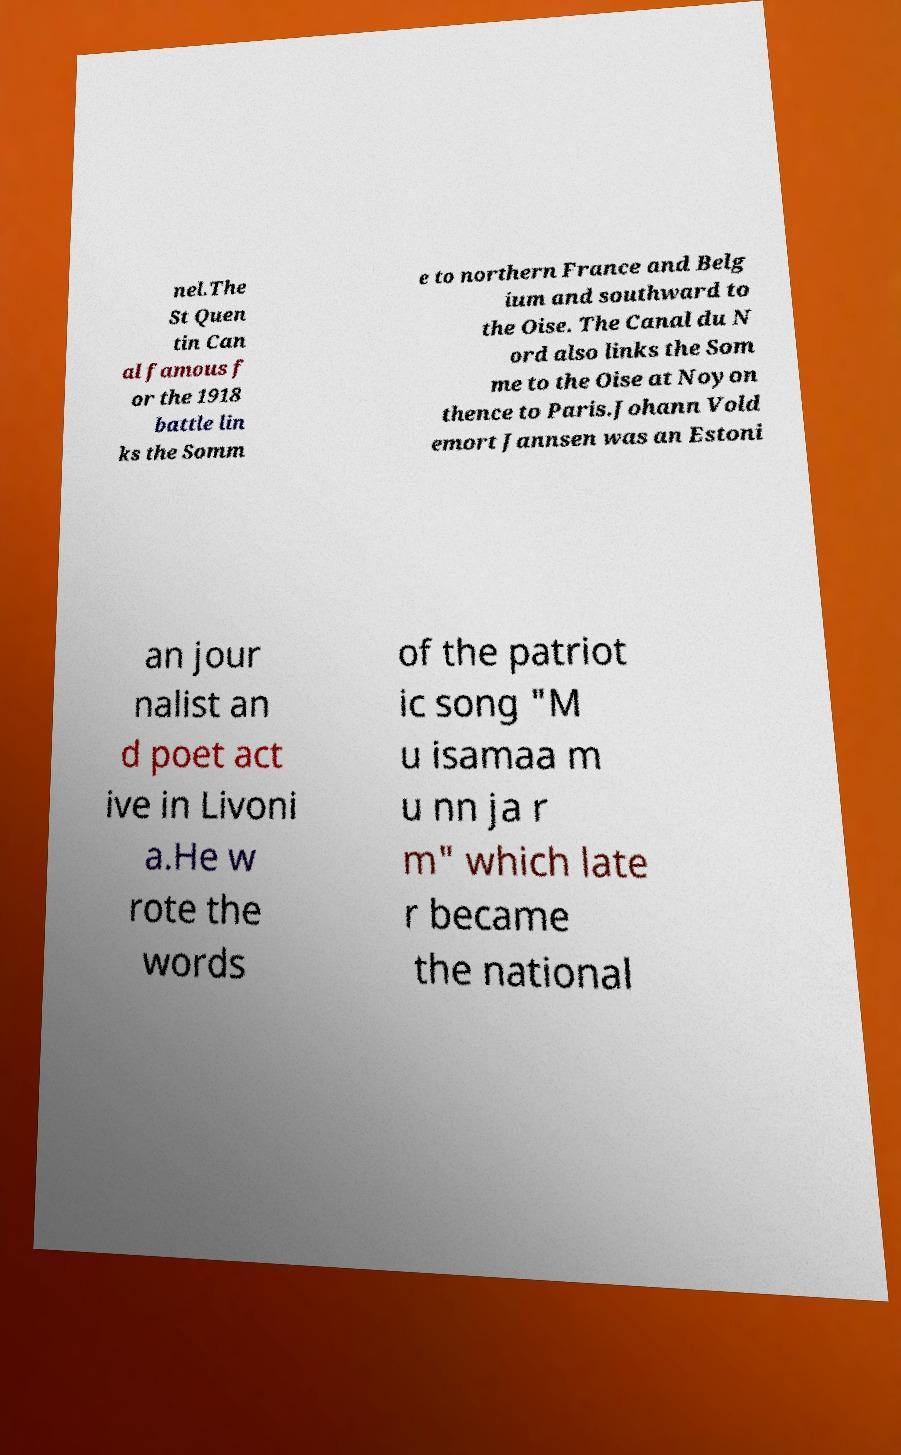Could you assist in decoding the text presented in this image and type it out clearly? nel.The St Quen tin Can al famous f or the 1918 battle lin ks the Somm e to northern France and Belg ium and southward to the Oise. The Canal du N ord also links the Som me to the Oise at Noyon thence to Paris.Johann Vold emort Jannsen was an Estoni an jour nalist an d poet act ive in Livoni a.He w rote the words of the patriot ic song "M u isamaa m u nn ja r m" which late r became the national 